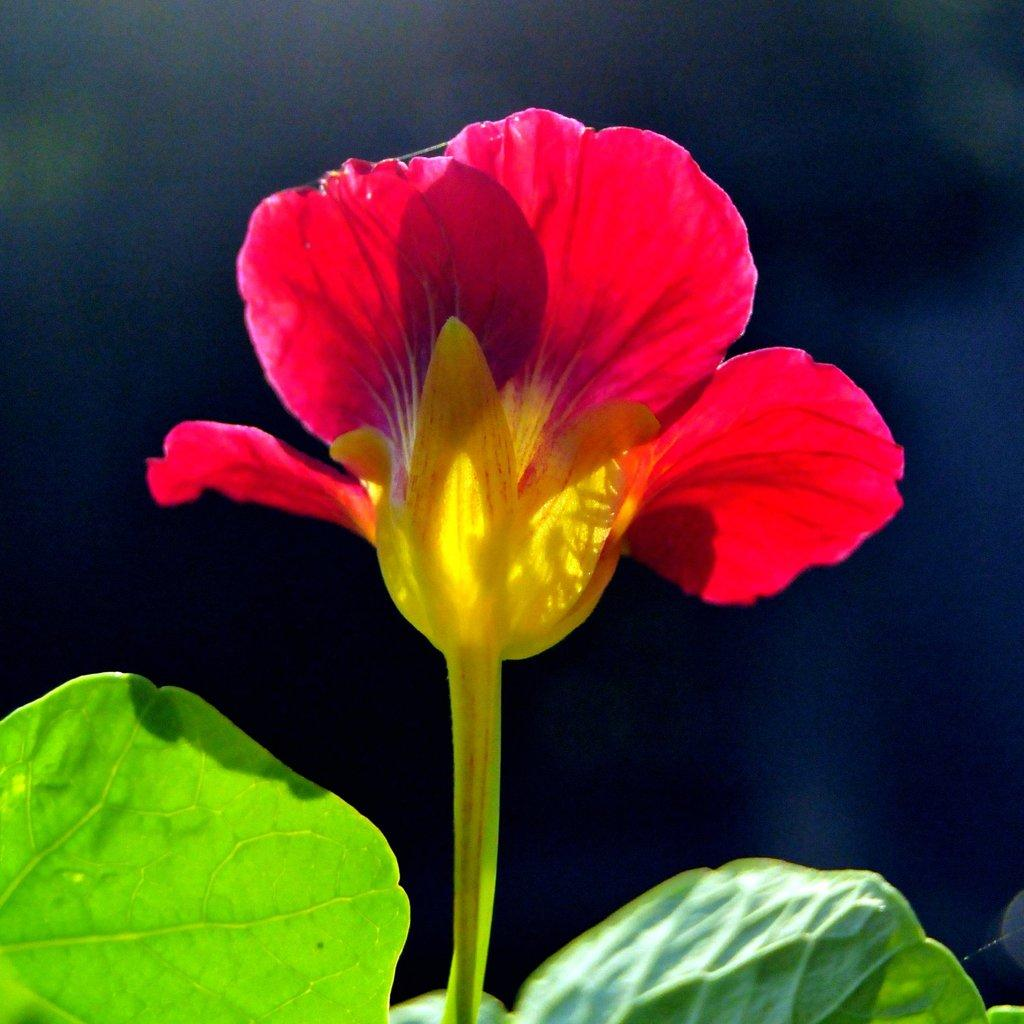What type of plant is visible in the image? There is a plant with a flower in the image. Can you describe the background of the image? The background of the image is blurry. What type of chess piece is sitting on the flower in the image? There is no chess piece present in the image; it features a plant with a flower and a blurry background. 